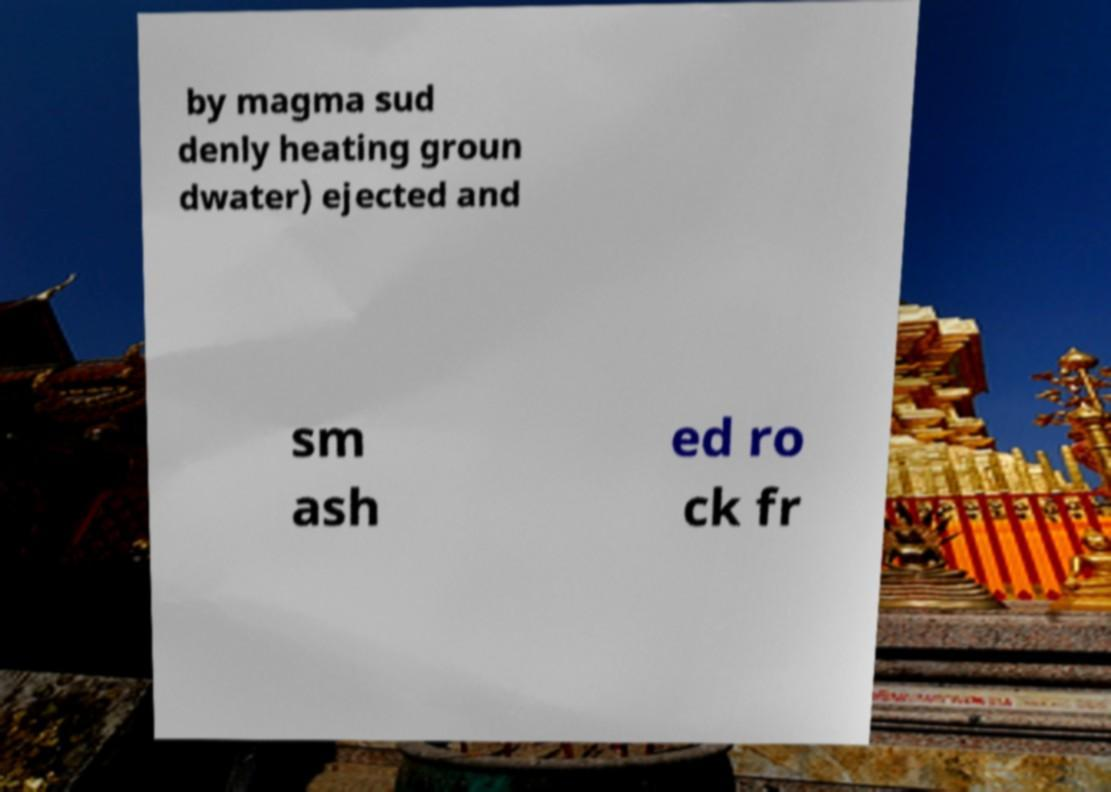There's text embedded in this image that I need extracted. Can you transcribe it verbatim? by magma sud denly heating groun dwater) ejected and sm ash ed ro ck fr 